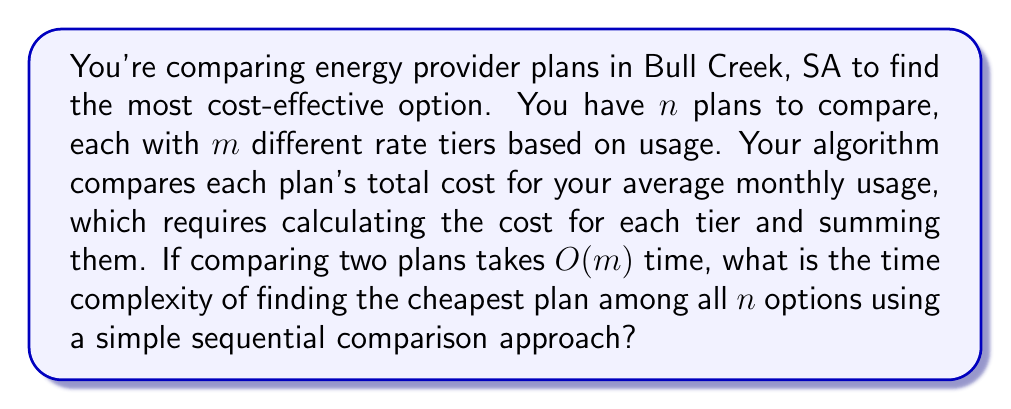What is the answer to this math problem? Let's break this down step-by-step:

1) First, we need to understand what the algorithm is doing:
   - We have $n$ plans to compare
   - Each plan has $m$ rate tiers
   - We need to compare each plan with every other plan

2) Comparing two plans takes $O(m)$ time because we need to calculate the cost for each of the $m$ tiers and sum them up.

3) Now, let's think about how many comparisons we need to make:
   - We start with the first plan and compare it to the remaining $(n-1)$ plans
   - Then we take the second plan and compare it to the remaining $(n-2)$ plans
   - We continue this process until we've compared all plans

4) The number of comparisons can be represented as:
   $$(n-1) + (n-2) + (n-3) + ... + 2 + 1 = \frac{n(n-1)}{2}$$

5) Each of these comparisons takes $O(m)$ time

6) Therefore, the total time complexity is:
   $$O(\frac{n(n-1)}{2} \cdot m)$$

7) Simplifying this expression:
   $$O(\frac{n^2m - nm}{2})$$

8) In Big O notation, we drop constants and lower order terms, so this simplifies to:
   $$O(n^2m)$$

This quadratic time complexity in terms of $n$ suggests that as the number of plans increases, the time to find the cheapest option will grow quickly.
Answer: $O(n^2m)$ 